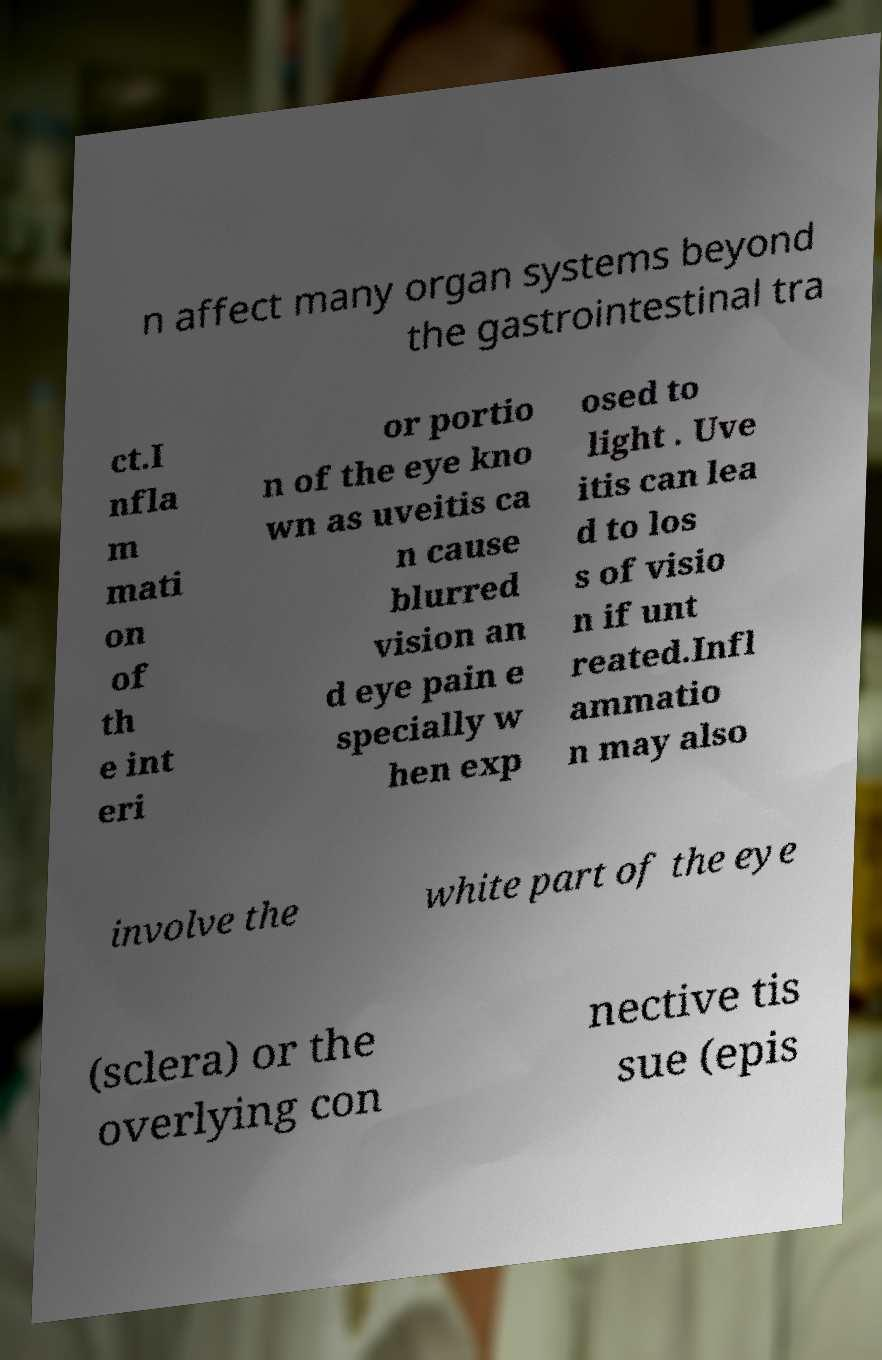I need the written content from this picture converted into text. Can you do that? n affect many organ systems beyond the gastrointestinal tra ct.I nfla m mati on of th e int eri or portio n of the eye kno wn as uveitis ca n cause blurred vision an d eye pain e specially w hen exp osed to light . Uve itis can lea d to los s of visio n if unt reated.Infl ammatio n may also involve the white part of the eye (sclera) or the overlying con nective tis sue (epis 